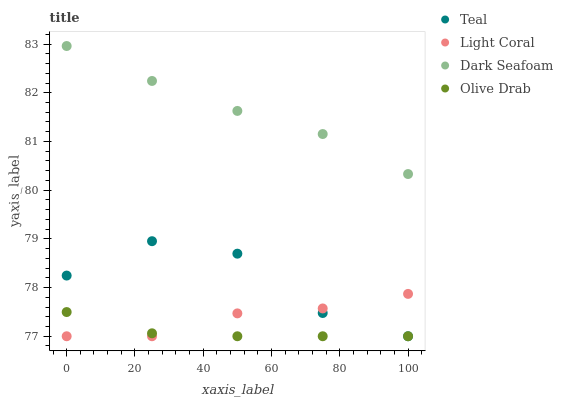Does Olive Drab have the minimum area under the curve?
Answer yes or no. Yes. Does Dark Seafoam have the maximum area under the curve?
Answer yes or no. Yes. Does Dark Seafoam have the minimum area under the curve?
Answer yes or no. No. Does Olive Drab have the maximum area under the curve?
Answer yes or no. No. Is Olive Drab the smoothest?
Answer yes or no. Yes. Is Teal the roughest?
Answer yes or no. Yes. Is Dark Seafoam the smoothest?
Answer yes or no. No. Is Dark Seafoam the roughest?
Answer yes or no. No. Does Light Coral have the lowest value?
Answer yes or no. Yes. Does Dark Seafoam have the lowest value?
Answer yes or no. No. Does Dark Seafoam have the highest value?
Answer yes or no. Yes. Does Olive Drab have the highest value?
Answer yes or no. No. Is Olive Drab less than Dark Seafoam?
Answer yes or no. Yes. Is Dark Seafoam greater than Light Coral?
Answer yes or no. Yes. Does Olive Drab intersect Teal?
Answer yes or no. Yes. Is Olive Drab less than Teal?
Answer yes or no. No. Is Olive Drab greater than Teal?
Answer yes or no. No. Does Olive Drab intersect Dark Seafoam?
Answer yes or no. No. 